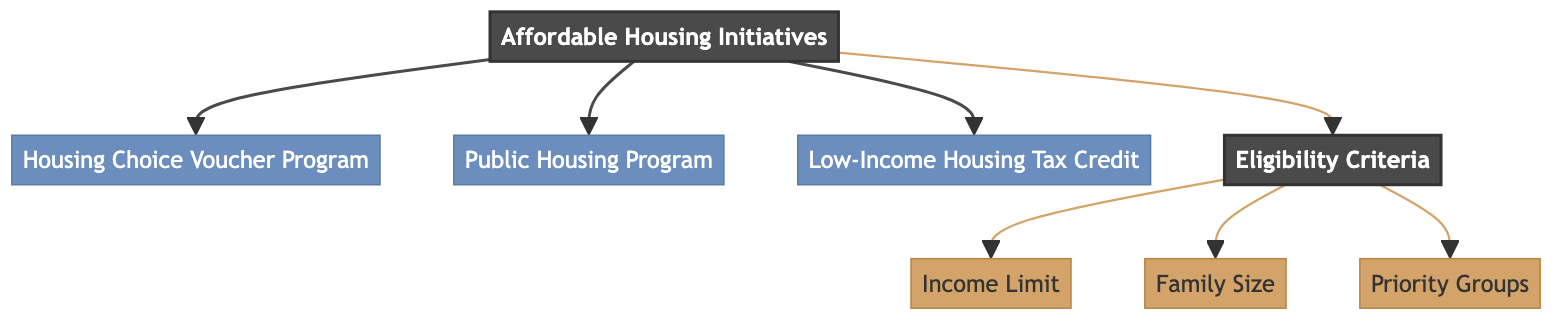What are the three main affordable housing initiatives? The diagram explicitly shows three main initiatives under the "Affordable Housing Initiatives": the Housing Choice Voucher Program, Public Housing Program, and Low-Income Housing Tax Credit.
Answer: Housing Choice Voucher Program, Public Housing Program, Low-Income Housing Tax Credit What is the main category from which other elements branch off? The diagram indicates that "Affordable Housing Initiatives" is the main node from which the other programs and criteria branch off.
Answer: Affordable Housing Initiatives How many eligibility criteria nodes are shown in the diagram? There are three eligibility criteria nodes: Income Limit, Family Size, and Priority Groups. Counting these nodes gives a total of three.
Answer: 3 What is the first eligibility criterion listed? The diagram shows that "Income Limit" is the first node listed under the Eligibility Criteria.
Answer: Income Limit Which initiative is linked directly to the Affordable Housing Initiatives? The diagram indicates that the "Housing Choice Voucher Program" is directly linked as one of the initiatives branching from the main node.
Answer: Housing Choice Voucher Program What do the eligibility criteria focus on based on the diagram? The eligibility criteria, including Income Limit, Family Size, and Priority Groups, focus on different factors to determine eligibility for affordable housing. They are grouped under the broader category of Eligibility Criteria.
Answer: Factors related to eligibility Are the nodes connected by dotted or solid lines? The connections between the main nodes and sub-nodes, including the eligibility criteria, are represented by solid lines.
Answer: Solid lines Which program has the same node level as "Public Housing Program"? Based on the diagram's structure, the "Low-Income Housing Tax Credit" shares the same node level as "Public Housing Program," as both are sub-nodes of "Affordable Housing Initiatives."
Answer: Low-Income Housing Tax Credit 